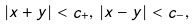Convert formula to latex. <formula><loc_0><loc_0><loc_500><loc_500>| x + y | < c _ { + } , \, | x - y | < c _ { - } ,</formula> 